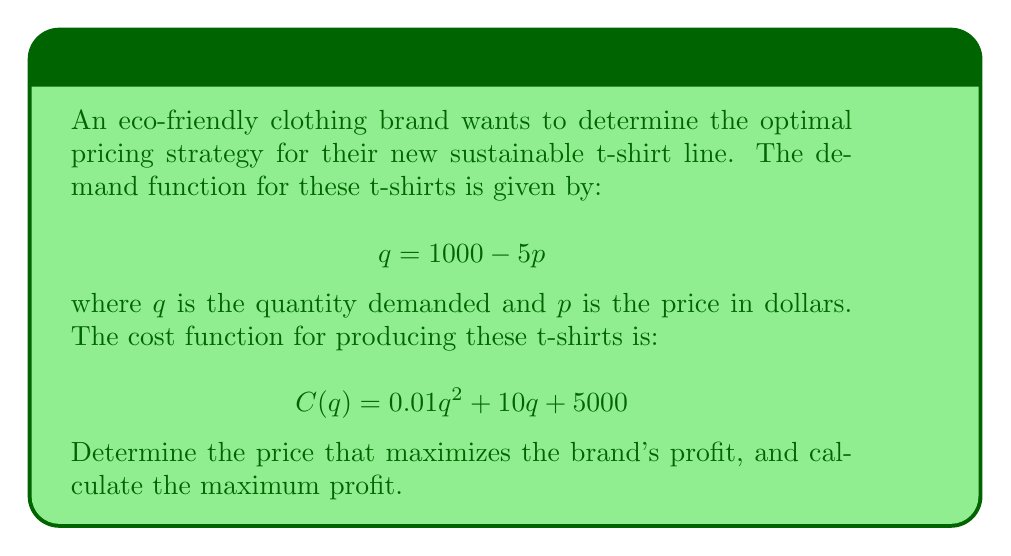Provide a solution to this math problem. 1) First, we need to express the revenue and profit functions in terms of p:
   Revenue: $R(p) = pq = p(1000 - 5p) = 1000p - 5p^2$
   
   Cost: $C(p) = 0.01(1000 - 5p)^2 + 10(1000 - 5p) + 5000$
   
   Profit: $\Pi(p) = R(p) - C(p)$

2) Expand the profit function:
   $\Pi(p) = (1000p - 5p^2) - [0.01(1000000 - 10000p + 25p^2) + 10000 - 50p + 5000]$
   $\Pi(p) = 1000p - 5p^2 - 10000 + 100p - 0.25p^2 - 10000 + 50p + 5000$
   $\Pi(p) = -5.25p^2 + 1150p - 25000$

3) To find the maximum profit, we need to find where the derivative of the profit function equals zero:
   $\frac{d\Pi}{dp} = -10.5p + 1150 = 0$

4) Solve for p:
   $-10.5p = -1150$
   $p = \frac{1150}{10.5} \approx 109.52$

5) The second derivative is negative $(-10.5 < 0)$, confirming this is a maximum.

6) Calculate the maximum profit by substituting this price back into the profit function:
   $\Pi(109.52) = -5.25(109.52)^2 + 1150(109.52) - 25000 \approx 37,797.62$
Answer: Optimal price: $\$109.52$; Maximum profit: $\$37,797.62$ 